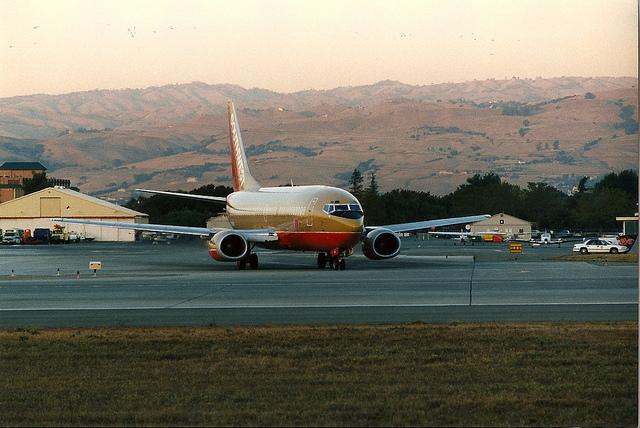What is in the background of the photo?
Be succinct. Mountains. Which is the color of the plane?
Concise answer only. Gold and red. Is the plane in motion?
Be succinct. No. What kind of vehicle is in the photo?
Quick response, please. Airplane. 